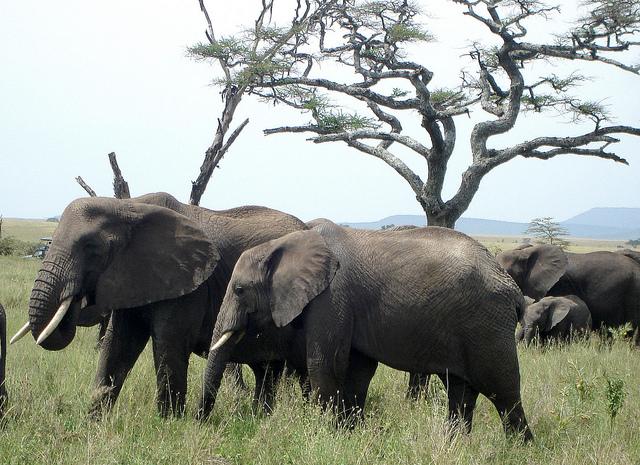What animal is present?
Answer briefly. Elephant. How many babies are present?
Be succinct. 1. Are the elephants in the shade?
Answer briefly. No. 